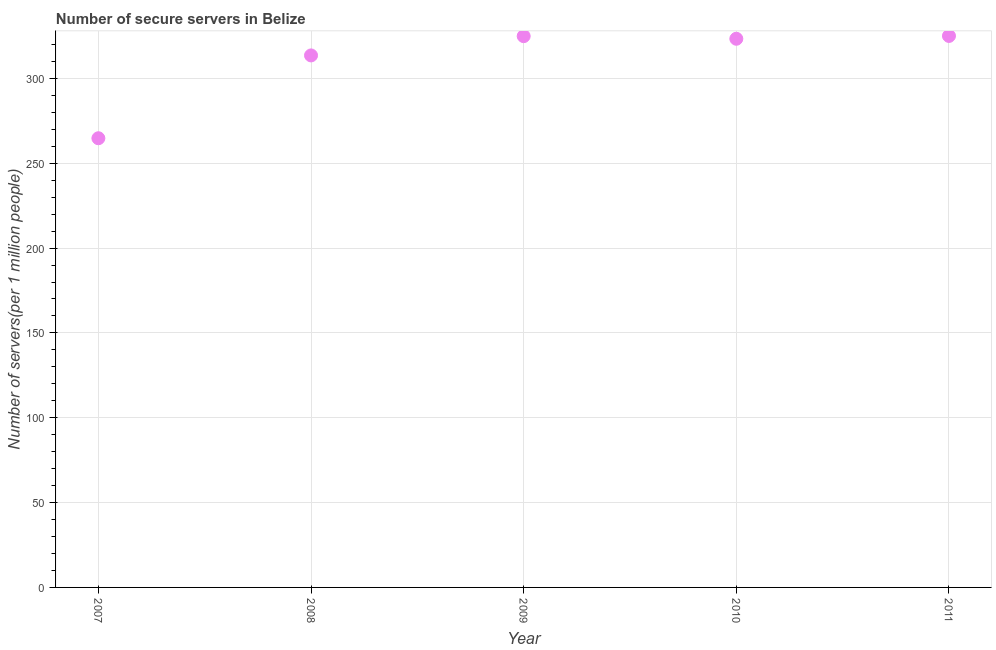What is the number of secure internet servers in 2011?
Your answer should be very brief. 325.04. Across all years, what is the maximum number of secure internet servers?
Your answer should be compact. 325.04. Across all years, what is the minimum number of secure internet servers?
Make the answer very short. 264.74. In which year was the number of secure internet servers maximum?
Keep it short and to the point. 2011. What is the sum of the number of secure internet servers?
Offer a terse response. 1551.63. What is the difference between the number of secure internet servers in 2008 and 2009?
Give a very brief answer. -11.36. What is the average number of secure internet servers per year?
Ensure brevity in your answer.  310.33. What is the median number of secure internet servers?
Offer a terse response. 323.37. In how many years, is the number of secure internet servers greater than 100 ?
Make the answer very short. 5. Do a majority of the years between 2007 and 2008 (inclusive) have number of secure internet servers greater than 40 ?
Offer a very short reply. Yes. What is the ratio of the number of secure internet servers in 2007 to that in 2008?
Your answer should be very brief. 0.84. What is the difference between the highest and the second highest number of secure internet servers?
Provide a short and direct response. 0.12. Is the sum of the number of secure internet servers in 2007 and 2011 greater than the maximum number of secure internet servers across all years?
Offer a very short reply. Yes. What is the difference between the highest and the lowest number of secure internet servers?
Your response must be concise. 60.29. What is the difference between two consecutive major ticks on the Y-axis?
Your answer should be compact. 50. Are the values on the major ticks of Y-axis written in scientific E-notation?
Provide a succinct answer. No. Does the graph contain grids?
Keep it short and to the point. Yes. What is the title of the graph?
Ensure brevity in your answer.  Number of secure servers in Belize. What is the label or title of the X-axis?
Ensure brevity in your answer.  Year. What is the label or title of the Y-axis?
Ensure brevity in your answer.  Number of servers(per 1 million people). What is the Number of servers(per 1 million people) in 2007?
Offer a terse response. 264.74. What is the Number of servers(per 1 million people) in 2008?
Your answer should be very brief. 313.56. What is the Number of servers(per 1 million people) in 2009?
Your answer should be compact. 324.92. What is the Number of servers(per 1 million people) in 2010?
Provide a short and direct response. 323.37. What is the Number of servers(per 1 million people) in 2011?
Make the answer very short. 325.04. What is the difference between the Number of servers(per 1 million people) in 2007 and 2008?
Give a very brief answer. -48.81. What is the difference between the Number of servers(per 1 million people) in 2007 and 2009?
Your answer should be compact. -60.18. What is the difference between the Number of servers(per 1 million people) in 2007 and 2010?
Your answer should be compact. -58.63. What is the difference between the Number of servers(per 1 million people) in 2007 and 2011?
Keep it short and to the point. -60.29. What is the difference between the Number of servers(per 1 million people) in 2008 and 2009?
Provide a succinct answer. -11.36. What is the difference between the Number of servers(per 1 million people) in 2008 and 2010?
Provide a succinct answer. -9.82. What is the difference between the Number of servers(per 1 million people) in 2008 and 2011?
Ensure brevity in your answer.  -11.48. What is the difference between the Number of servers(per 1 million people) in 2009 and 2010?
Make the answer very short. 1.54. What is the difference between the Number of servers(per 1 million people) in 2009 and 2011?
Provide a succinct answer. -0.12. What is the difference between the Number of servers(per 1 million people) in 2010 and 2011?
Offer a terse response. -1.66. What is the ratio of the Number of servers(per 1 million people) in 2007 to that in 2008?
Ensure brevity in your answer.  0.84. What is the ratio of the Number of servers(per 1 million people) in 2007 to that in 2009?
Keep it short and to the point. 0.81. What is the ratio of the Number of servers(per 1 million people) in 2007 to that in 2010?
Offer a very short reply. 0.82. What is the ratio of the Number of servers(per 1 million people) in 2007 to that in 2011?
Your answer should be very brief. 0.81. What is the ratio of the Number of servers(per 1 million people) in 2008 to that in 2009?
Offer a terse response. 0.96. What is the ratio of the Number of servers(per 1 million people) in 2009 to that in 2010?
Offer a very short reply. 1. What is the ratio of the Number of servers(per 1 million people) in 2009 to that in 2011?
Give a very brief answer. 1. 